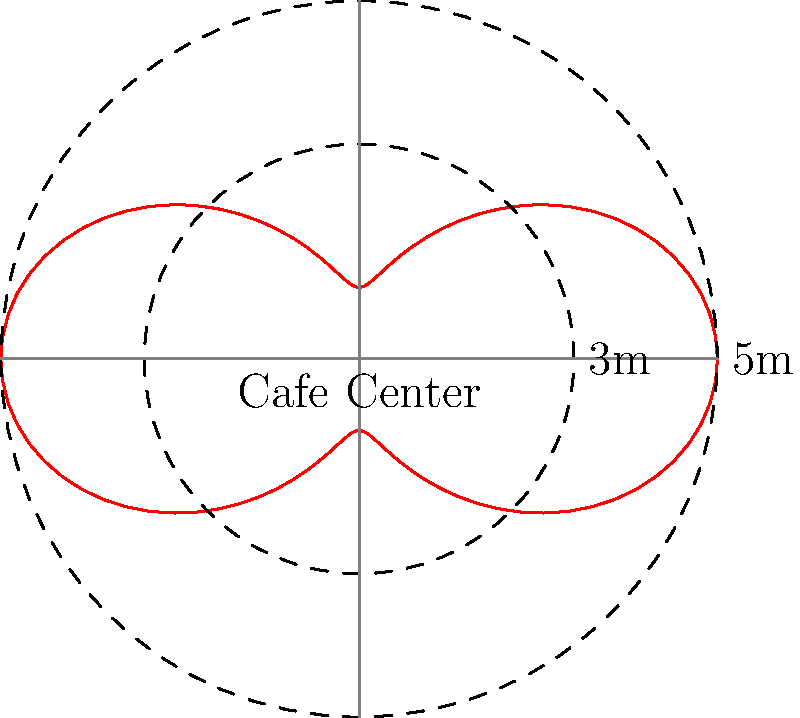In memory of the late cafe owner, you're analyzing the seating arrangement. The polar curve $r = 3 + 2\cos(2\theta)$ represents the distribution of tables from the cafe's center. What's the maximum distance (in meters) a table can be from the center, and how does this relate to the owner's philosophy of creating intimate yet spacious seating? To find the maximum distance of a table from the cafe's center, we need to follow these steps:

1) The given polar equation is $r = 3 + 2\cos(2\theta)$.

2) The maximum value of $r$ occurs when $\cos(2\theta)$ is at its maximum, which is 1.

3) Therefore, the maximum value of $r$ is:
   $$r_{max} = 3 + 2(1) = 5$$

4) This means the maximum distance a table can be from the center is 5 meters.

5) Relating to the owner's philosophy:
   - The minimum distance (when $\cos(2\theta) = -1$) is 1 meter, allowing for intimate seating near the center.
   - The maximum distance of 5 meters provides spacious seating options.
   - The variation between 1 and 5 meters offers a range of seating experiences, balancing intimacy and space.

6) The curve's shape, with four "petals", suggests four main seating areas, possibly representing the owner's desire for a well-organized yet organic layout.
Answer: 5 meters; balances intimacy and spaciousness 